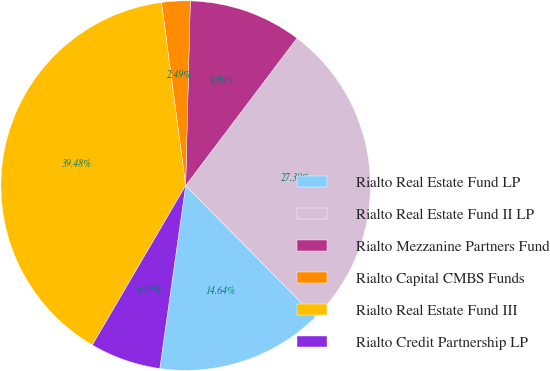<chart> <loc_0><loc_0><loc_500><loc_500><pie_chart><fcel>Rialto Real Estate Fund LP<fcel>Rialto Real Estate Fund II LP<fcel>Rialto Mezzanine Partners Fund<fcel>Rialto Capital CMBS Funds<fcel>Rialto Real Estate Fund III<fcel>Rialto Credit Partnership LP<nl><fcel>14.64%<fcel>27.3%<fcel>9.89%<fcel>2.49%<fcel>39.48%<fcel>6.19%<nl></chart> 